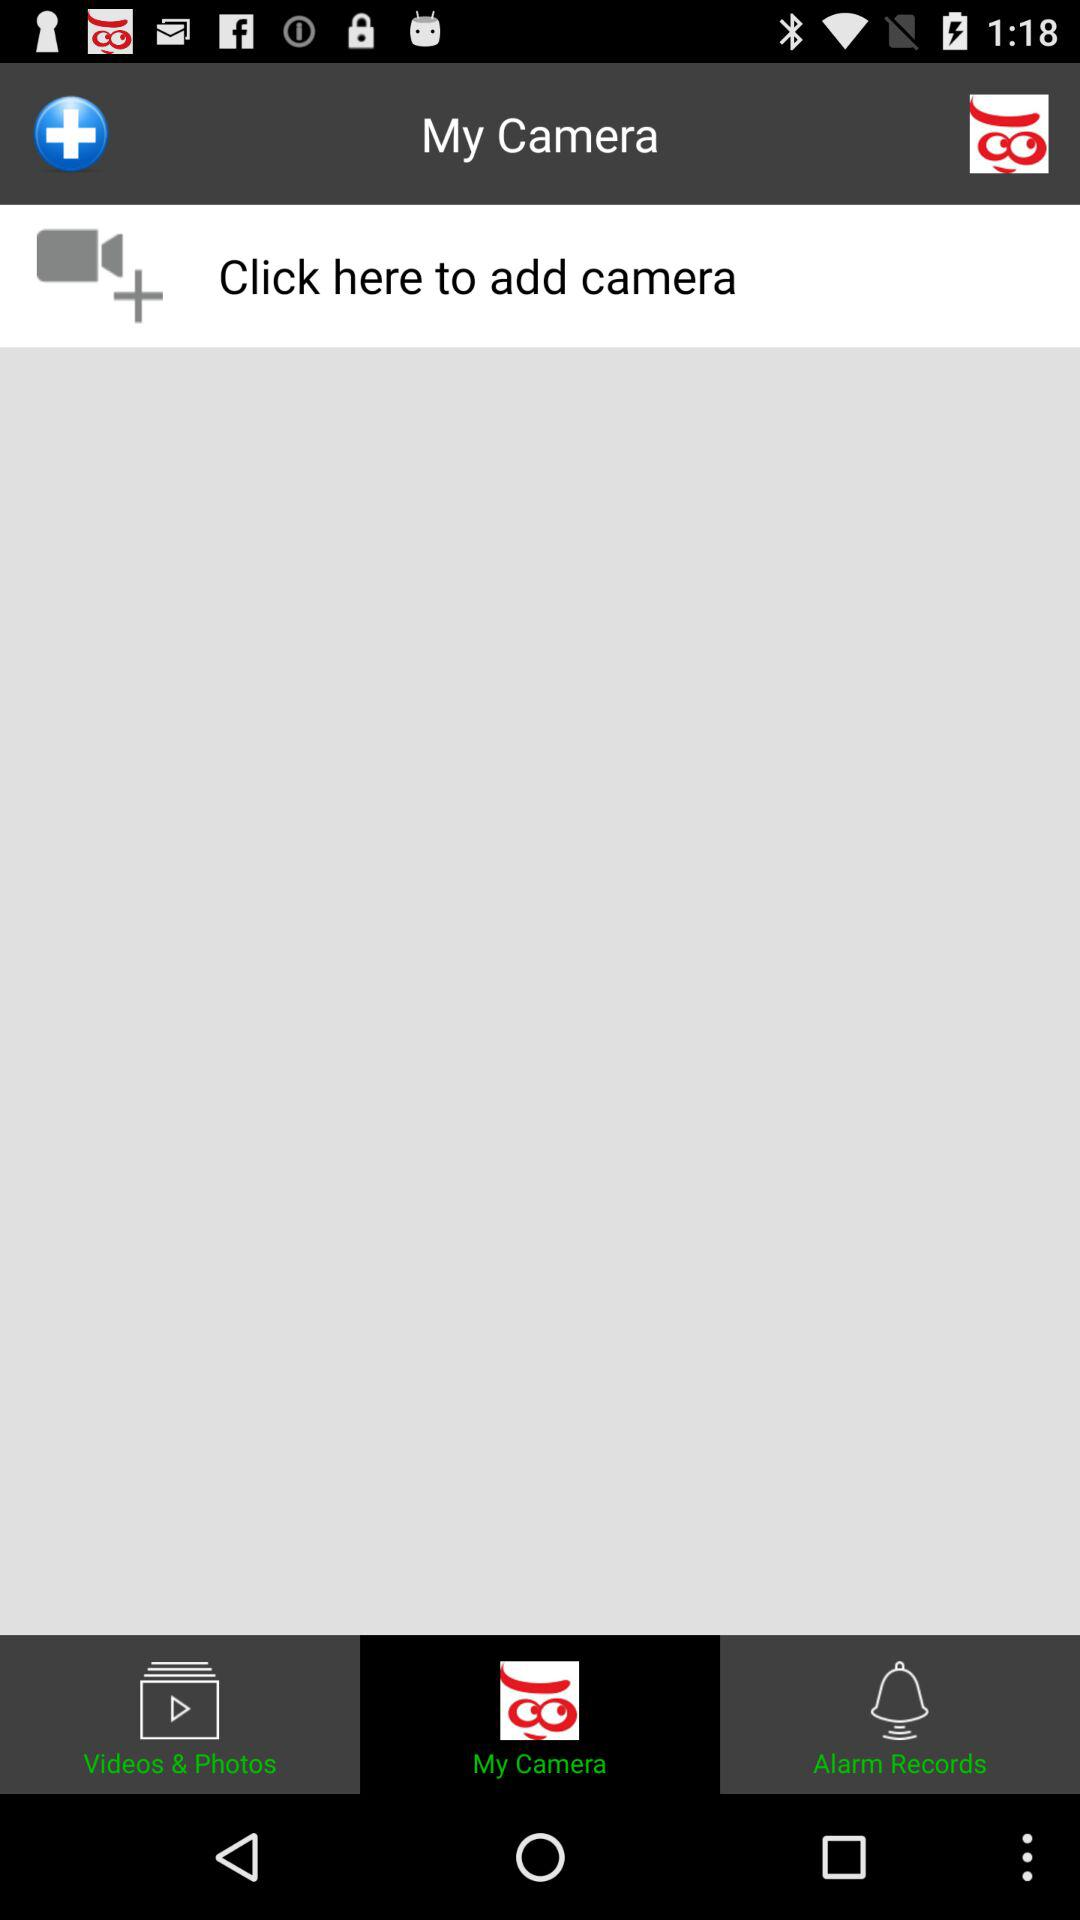What is the selected tab? The selected tab is "My Camera". 